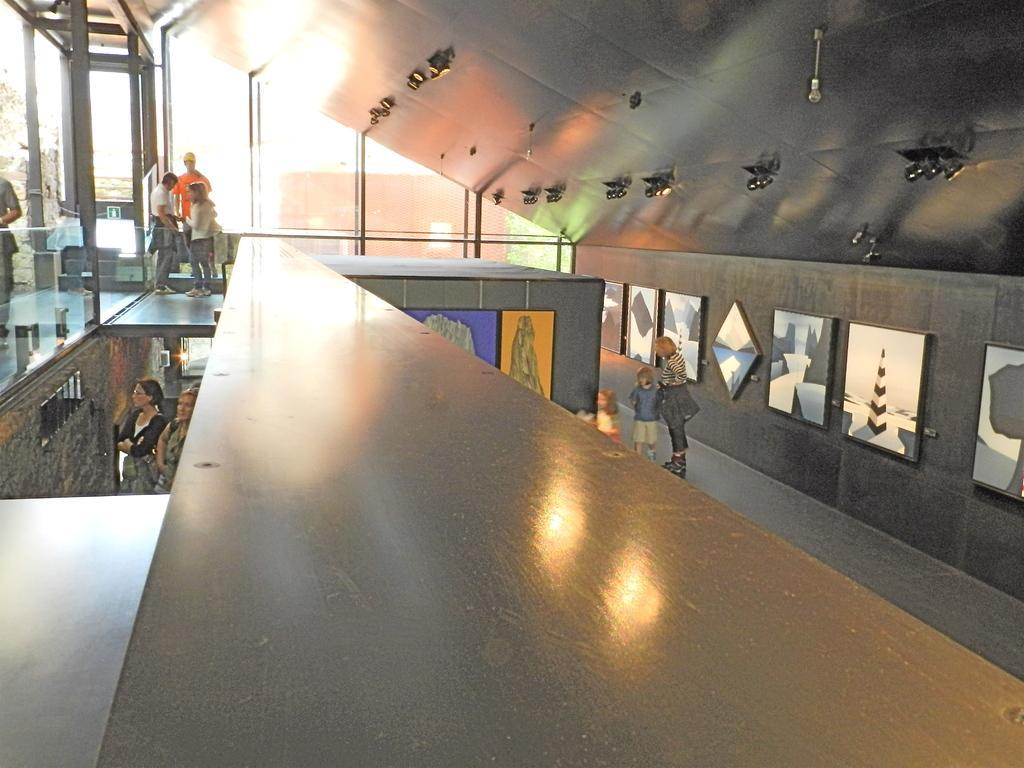In one or two sentences, can you explain what this image depicts? In the center of the image we can see one wooden solid structure. In the background there is a wall, photo frames, poles, few people are standing, few people are holding some objects and a few other objects. 